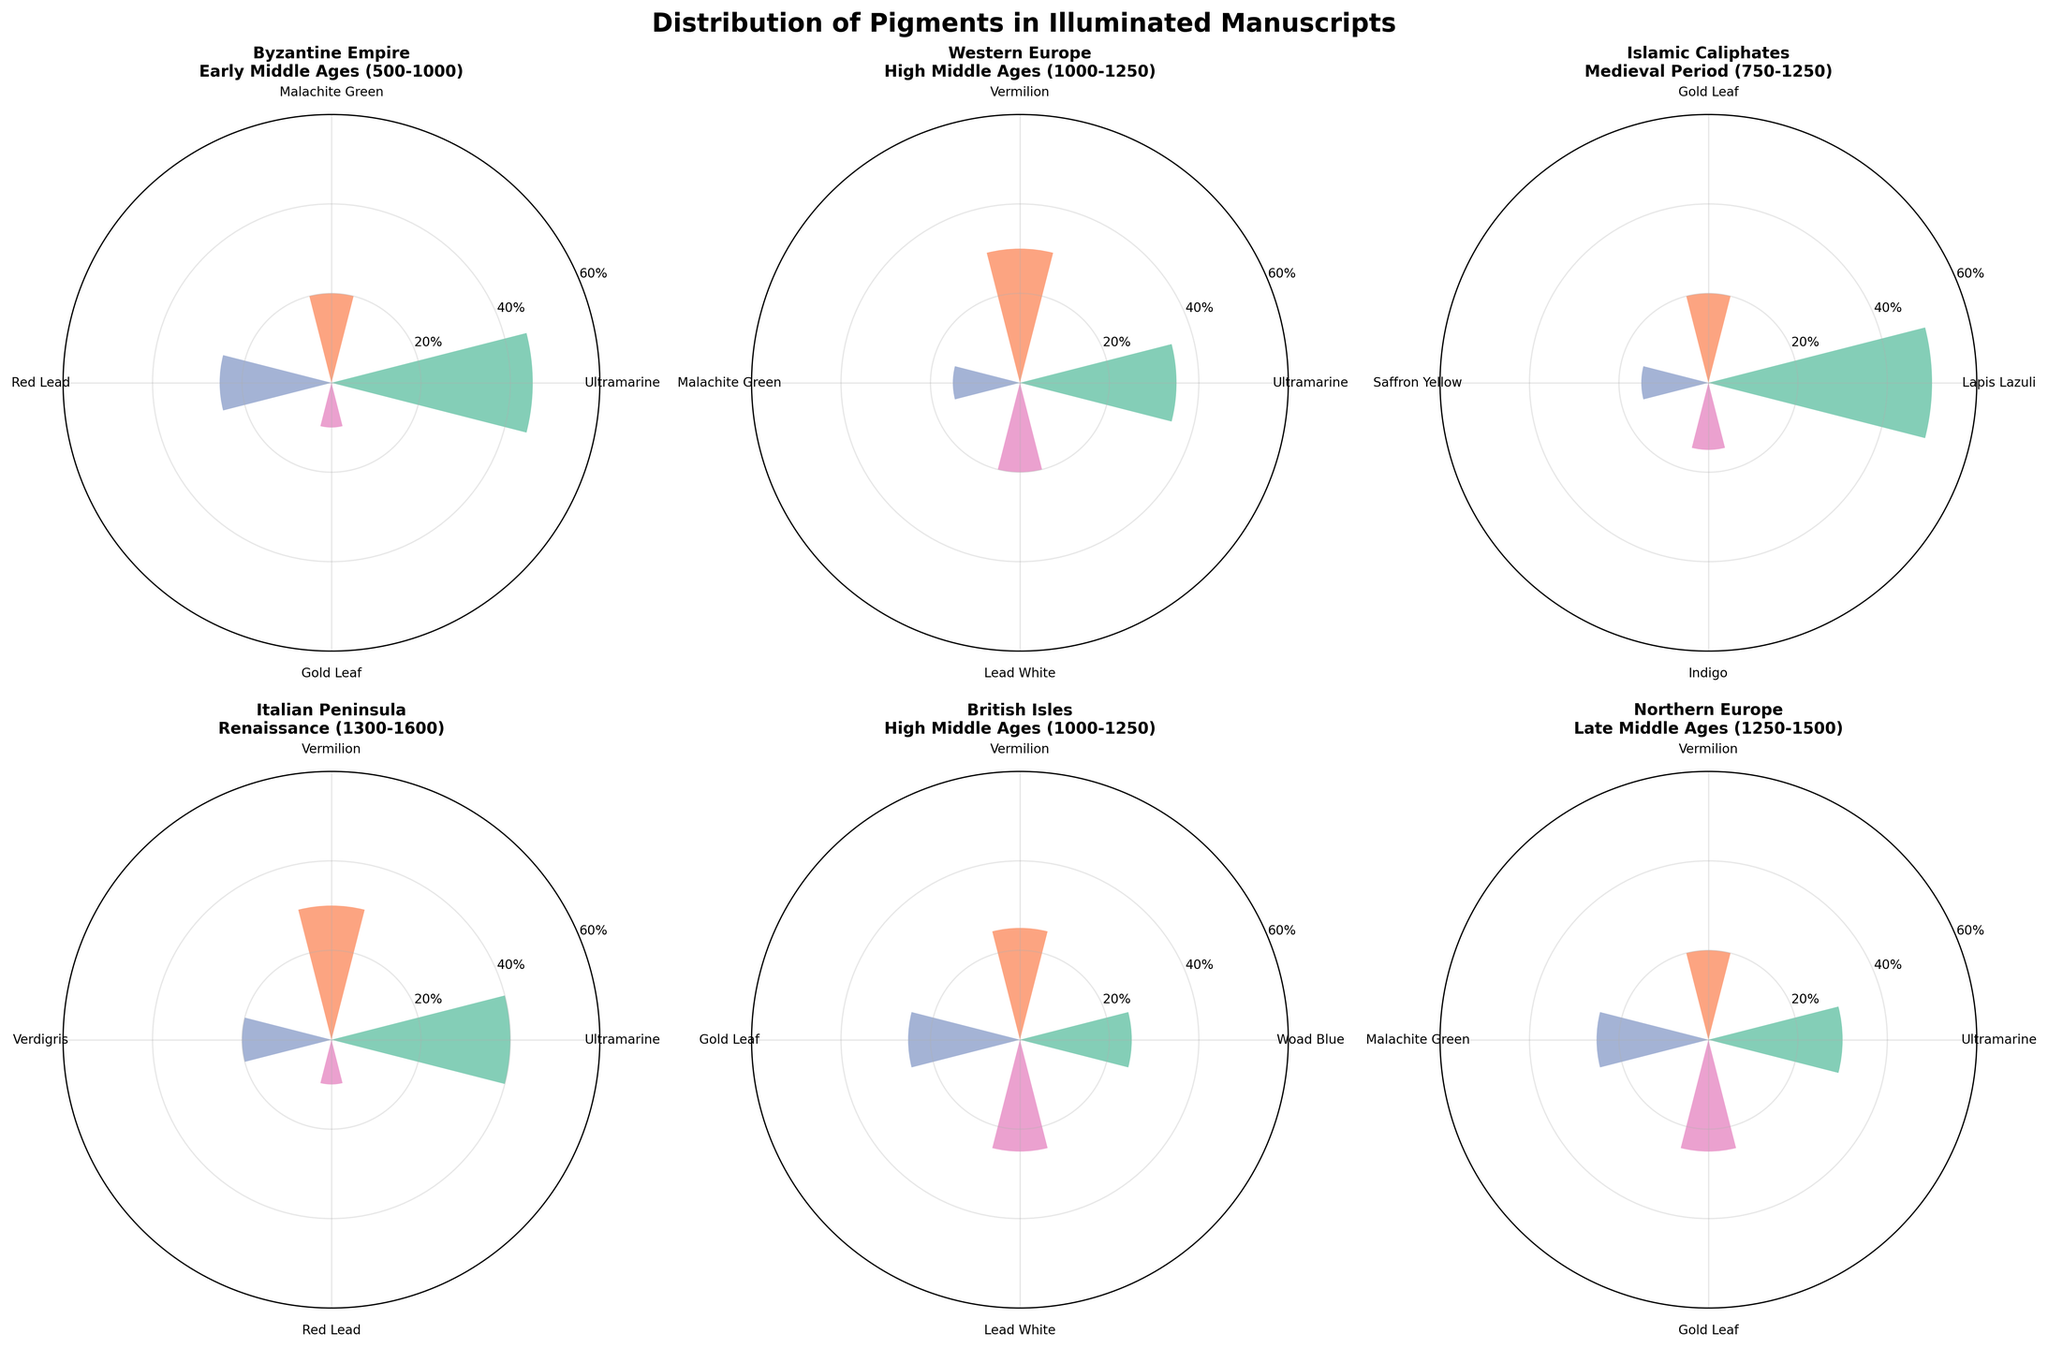What is the most common pigment in manuscripts from the Byzantine Empire during the Early Middle Ages? The subplot for the Byzantine Empire shows Ultramarine as the pigment with the highest percentage.
Answer: Ultramarine Which geographic location had the highest usage of Gold Leaf in their illuminated manuscripts? Comparing the percentages of Gold Leaf across all subplots: Byzantine Empire (10%), Islamic Caliphates (20%), British Isles (25%), Northern Europe (25%). The highest usage is in the British Isles and Northern Europe.
Answer: British Isles, Northern Europe Are there any pigments that were consistently used across all geographic locations and periods? Examining each subplot, Ultramarine and Vermilion appear in multiple, but not all. No single pigment is present in all subplots.
Answer: No Which geographic location during the High Middle Ages (1000-1250) shows a balanced use of pigments in illuminated manuscripts? The subplot for the British Isles shows 25% usage for Woad Blue, Vermilion, Gold Leaf, and Lead White, indicating a balanced distribution.
Answer: British Isles In which period and location was Lapis Lazuli most predominantly used? The subplot for the Islamic Caliphates in the Medieval Period shows Lapis Lazuli at 50%, which is the highest usage of this pigment.
Answer: Islamic Caliphates, Medieval Period What percentage of Malachite Green was used in Western Europe during the High Middle Ages compared to Northern Europe during the Late Middle Ages? Western Europe shown with 15% Malachite Green and Northern Europe with 25%.
Answer: 15% in Western Europe, 25% in Northern Europe Which period and location show the most diverse range of pigments used? The Byzantine Empire during the Early Middle Ages shows four distinct pigments, similar to other locations. Additional visual or detailed examination may be needed for exact diversity comparison.
Answer: Needs detailed comparison How does the use of Vermilion in the Italian Peninsula during the Renaissance compare to its use in Western Europe during the High Middle Ages? The subplot for the Italian Peninsula shows 30% Vermilion, while Western Europe shows 30% as well, indicating equal usage.
Answer: Equal (30%) Which location and period display the least use of Ultramarine in illuminated manuscripts? Western Europe during the High Middle Ages shows 35% Ultramarine, higher than 40% in the Byzantine Empire and Italian Peninsula, Northern Europe's 30% is the minimal usage among the locations.
Answer: Northern Europe, Late Middle Ages What is the cumulative percentage of red pigments (e.g., Vermilion, Red Lead) used in the Byzantine Empire during the Early Middle Ages? Summing the percentages for Red Lead (25%) and Vermilion (not listed), only Red Lead's value is used.
Answer: 25% 